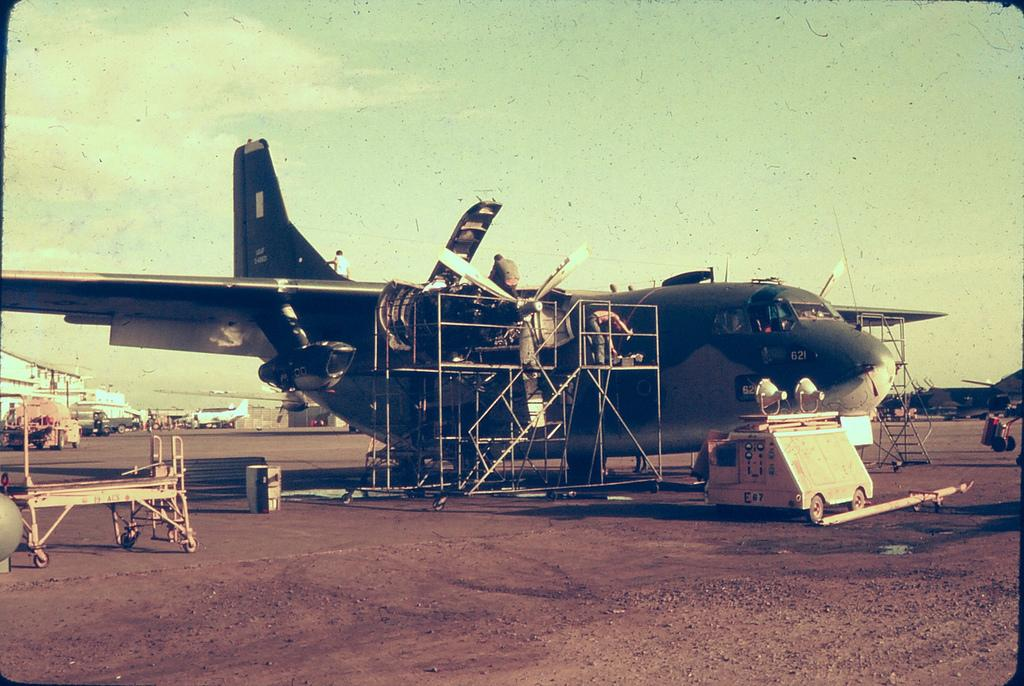What is the main subject of the image? The main subject of the image is many aircrafts. What can be seen in the background of the image? The sky is visible in the image. Are there any living beings present in the image? Yes, there are people in the image. What else can be seen in the image besides the aircrafts and people? There are objects in the image. What language is being spoken by the people in the image? There is no information about the language being spoken by the people in the image. Can you see a crown on any of the aircrafts in the image? There is no crown present on any of the aircrafts in the image. 